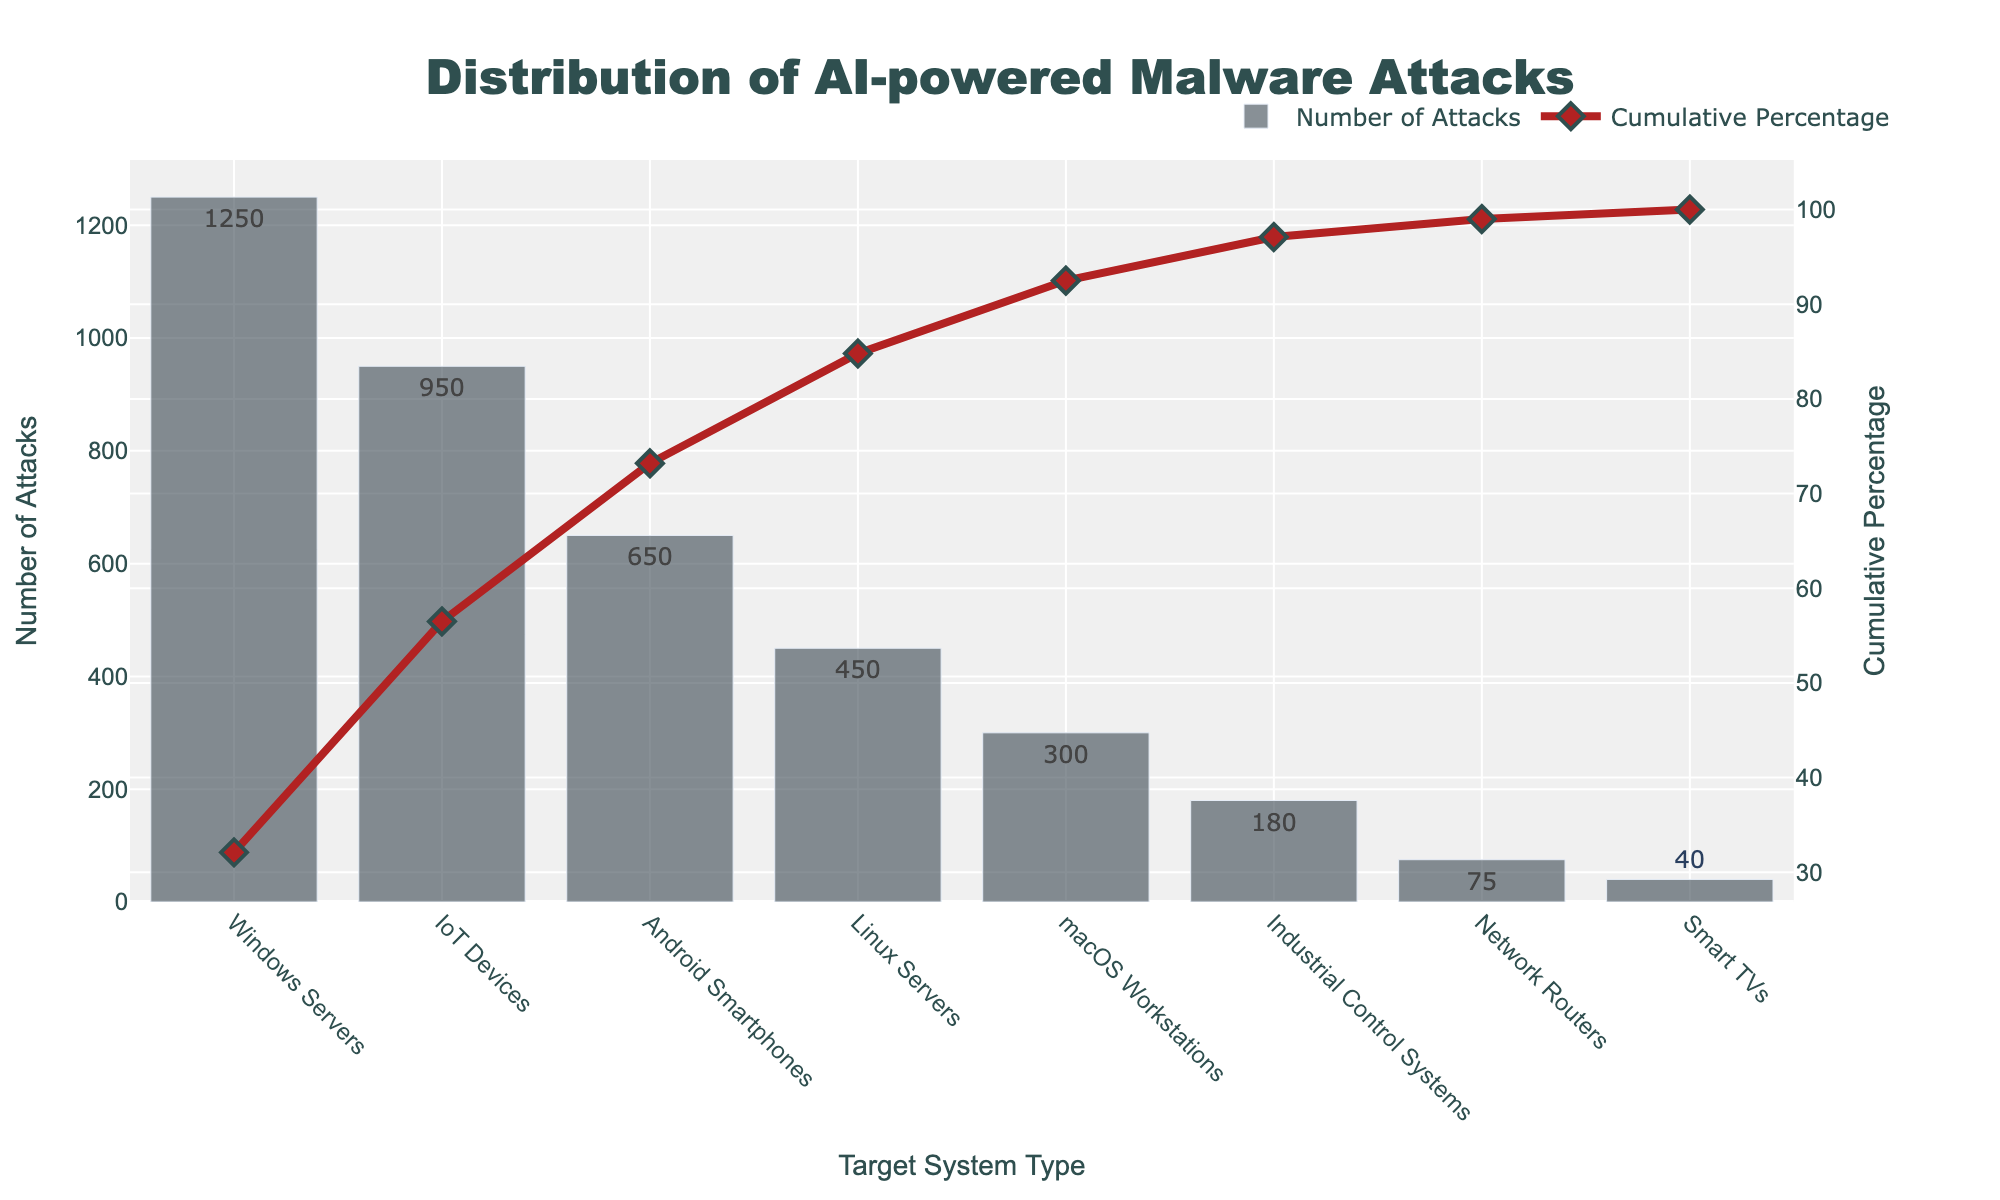What is the title of the figure? The title is located at the top of the figure and reads: "Distribution of AI-powered Malware Attacks".
Answer: Distribution of AI-powered Malware Attacks How many types of target systems are represented in the chart? The chart has data points with labels on the x-axis, one for each type of target system. Counting these labels gives us a total.
Answer: 8 Which target system type experienced the highest number of attacks? The height of the bars in the bar chart component of the Pareto chart indicates the number of attacks for each system type. The tallest bar represents the highest number of attacks.
Answer: Windows Servers What is the cumulative percentage of attacks after including IoT Devices? The cumulative percentage line chart shows the cumulative percentage of attacks. The value at the marker for IoT Devices is the cumulative percentage after including attacks on this system type.
Answer: 56.5% How many fewer attacks did Network Routers experience compared to IoT Devices? The number of attacks for IoT Devices is 950, and for Network Routers, it is 75. Subtracting these gives the difference.
Answer: 875 Which two system types have cumulative percentages that fall between 80% and 100%? We look at the cumulative percentage values for each system type and find which ones are between 80% and 100%.
Answer: Linux Servers, macOS Workstations, Industrial Control Systems, Network Routers, Smart TVs What is the cumulative percentage increase from Windows Servers to Android Smartphones? We find the cumulative percentages for Windows Servers (32.1%) and Android Smartphones (73.2%) and subtract the smaller from the larger.
Answer: 41.1% Which system type has the smallest number of attacks, and what is the corresponding cumulative percentage? The smallest number of attacks corresponds to the shortest bar in the bar chart. The cumulative percentage at this point in the line chart gives us the answer.
Answer: Smart TVs, 100.0% How many more attacks did Android Smartphones experience compared to macOS Workstations? The number of attacks is 650 for Android Smartphones and 300 for macOS Workstations. The difference between these values provides the answer.
Answer: 350 What is the color used for the line representing cumulative percentage? The line color for cumulative percentage is a distinguishing feature; it is specified as 'firebrick'.
Answer: Red 